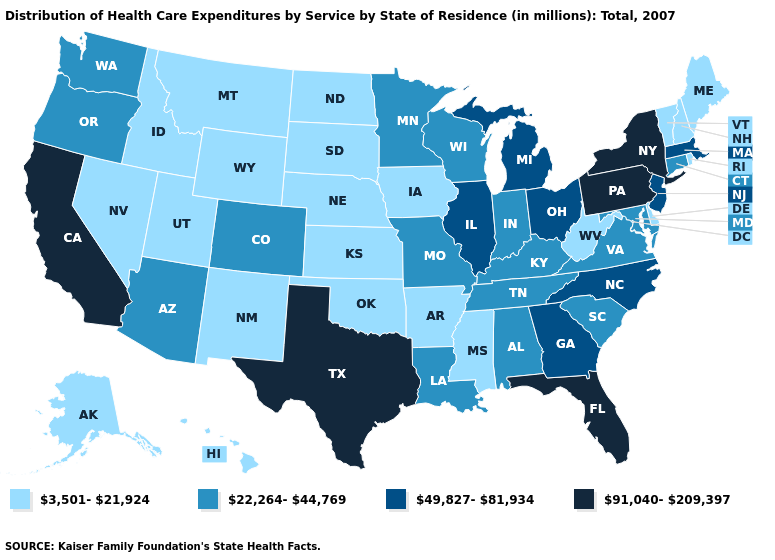Name the states that have a value in the range 91,040-209,397?
Short answer required. California, Florida, New York, Pennsylvania, Texas. How many symbols are there in the legend?
Write a very short answer. 4. What is the lowest value in states that border North Carolina?
Keep it brief. 22,264-44,769. Does California have the highest value in the USA?
Write a very short answer. Yes. Name the states that have a value in the range 22,264-44,769?
Keep it brief. Alabama, Arizona, Colorado, Connecticut, Indiana, Kentucky, Louisiana, Maryland, Minnesota, Missouri, Oregon, South Carolina, Tennessee, Virginia, Washington, Wisconsin. What is the value of Arkansas?
Answer briefly. 3,501-21,924. Among the states that border Nebraska , does Wyoming have the highest value?
Be succinct. No. Name the states that have a value in the range 3,501-21,924?
Be succinct. Alaska, Arkansas, Delaware, Hawaii, Idaho, Iowa, Kansas, Maine, Mississippi, Montana, Nebraska, Nevada, New Hampshire, New Mexico, North Dakota, Oklahoma, Rhode Island, South Dakota, Utah, Vermont, West Virginia, Wyoming. Among the states that border Kansas , does Oklahoma have the highest value?
Answer briefly. No. Among the states that border Vermont , does New York have the lowest value?
Short answer required. No. Which states have the lowest value in the USA?
Quick response, please. Alaska, Arkansas, Delaware, Hawaii, Idaho, Iowa, Kansas, Maine, Mississippi, Montana, Nebraska, Nevada, New Hampshire, New Mexico, North Dakota, Oklahoma, Rhode Island, South Dakota, Utah, Vermont, West Virginia, Wyoming. Among the states that border Texas , which have the lowest value?
Answer briefly. Arkansas, New Mexico, Oklahoma. Which states have the lowest value in the Northeast?
Short answer required. Maine, New Hampshire, Rhode Island, Vermont. What is the lowest value in the South?
Be succinct. 3,501-21,924. How many symbols are there in the legend?
Be succinct. 4. 